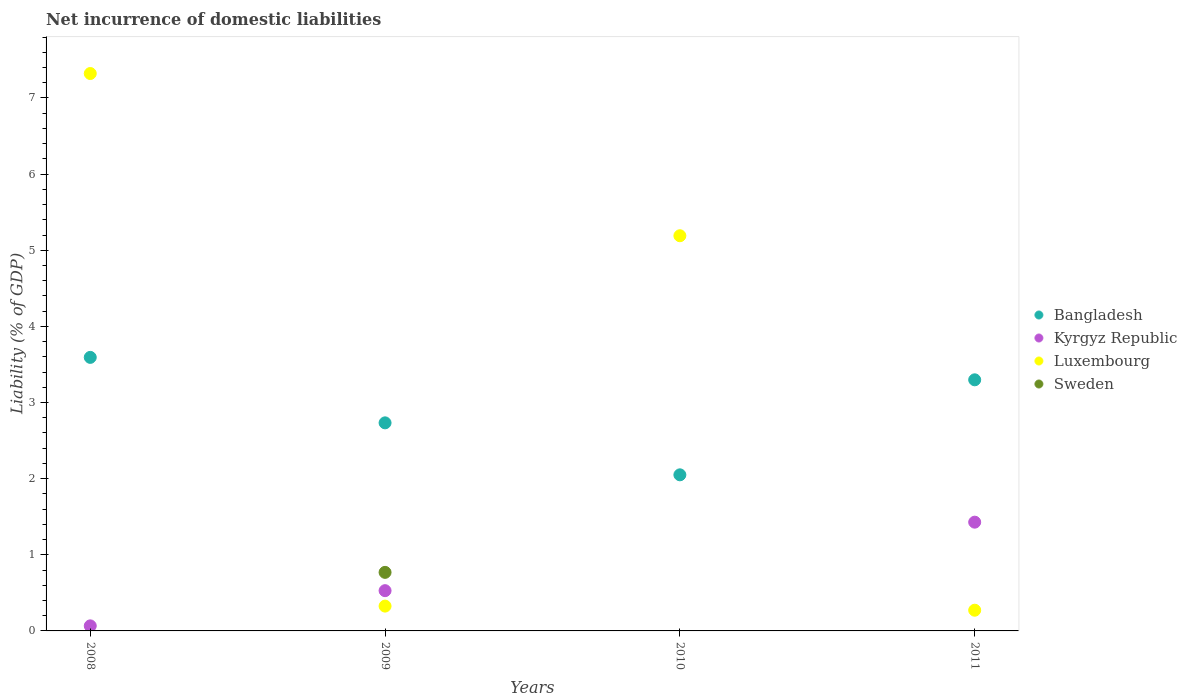Is the number of dotlines equal to the number of legend labels?
Provide a succinct answer. No. What is the net incurrence of domestic liabilities in Kyrgyz Republic in 2009?
Your response must be concise. 0.53. Across all years, what is the maximum net incurrence of domestic liabilities in Sweden?
Your answer should be very brief. 0.77. Across all years, what is the minimum net incurrence of domestic liabilities in Bangladesh?
Keep it short and to the point. 2.05. What is the total net incurrence of domestic liabilities in Bangladesh in the graph?
Ensure brevity in your answer.  11.67. What is the difference between the net incurrence of domestic liabilities in Bangladesh in 2008 and that in 2010?
Give a very brief answer. 1.54. What is the difference between the net incurrence of domestic liabilities in Bangladesh in 2011 and the net incurrence of domestic liabilities in Luxembourg in 2008?
Make the answer very short. -4.02. What is the average net incurrence of domestic liabilities in Bangladesh per year?
Make the answer very short. 2.92. In the year 2011, what is the difference between the net incurrence of domestic liabilities in Kyrgyz Republic and net incurrence of domestic liabilities in Luxembourg?
Your answer should be compact. 1.16. In how many years, is the net incurrence of domestic liabilities in Luxembourg greater than 7.4 %?
Provide a succinct answer. 0. What is the ratio of the net incurrence of domestic liabilities in Luxembourg in 2010 to that in 2011?
Keep it short and to the point. 19.09. Is the net incurrence of domestic liabilities in Luxembourg in 2009 less than that in 2010?
Your answer should be very brief. Yes. Is the difference between the net incurrence of domestic liabilities in Kyrgyz Republic in 2008 and 2009 greater than the difference between the net incurrence of domestic liabilities in Luxembourg in 2008 and 2009?
Your answer should be compact. No. What is the difference between the highest and the second highest net incurrence of domestic liabilities in Luxembourg?
Ensure brevity in your answer.  2.13. What is the difference between the highest and the lowest net incurrence of domestic liabilities in Sweden?
Your response must be concise. 0.77. In how many years, is the net incurrence of domestic liabilities in Sweden greater than the average net incurrence of domestic liabilities in Sweden taken over all years?
Ensure brevity in your answer.  1. Is the net incurrence of domestic liabilities in Sweden strictly greater than the net incurrence of domestic liabilities in Bangladesh over the years?
Offer a terse response. No. How many years are there in the graph?
Ensure brevity in your answer.  4. What is the difference between two consecutive major ticks on the Y-axis?
Your answer should be very brief. 1. Does the graph contain grids?
Make the answer very short. No. How many legend labels are there?
Offer a terse response. 4. How are the legend labels stacked?
Your response must be concise. Vertical. What is the title of the graph?
Keep it short and to the point. Net incurrence of domestic liabilities. What is the label or title of the X-axis?
Keep it short and to the point. Years. What is the label or title of the Y-axis?
Give a very brief answer. Liability (% of GDP). What is the Liability (% of GDP) in Bangladesh in 2008?
Offer a terse response. 3.59. What is the Liability (% of GDP) in Kyrgyz Republic in 2008?
Give a very brief answer. 0.07. What is the Liability (% of GDP) of Luxembourg in 2008?
Offer a very short reply. 7.32. What is the Liability (% of GDP) in Bangladesh in 2009?
Offer a very short reply. 2.73. What is the Liability (% of GDP) of Kyrgyz Republic in 2009?
Offer a terse response. 0.53. What is the Liability (% of GDP) of Luxembourg in 2009?
Offer a terse response. 0.33. What is the Liability (% of GDP) of Sweden in 2009?
Offer a terse response. 0.77. What is the Liability (% of GDP) of Bangladesh in 2010?
Offer a very short reply. 2.05. What is the Liability (% of GDP) in Kyrgyz Republic in 2010?
Keep it short and to the point. 0. What is the Liability (% of GDP) of Luxembourg in 2010?
Keep it short and to the point. 5.19. What is the Liability (% of GDP) of Sweden in 2010?
Give a very brief answer. 0. What is the Liability (% of GDP) in Bangladesh in 2011?
Provide a succinct answer. 3.3. What is the Liability (% of GDP) of Kyrgyz Republic in 2011?
Give a very brief answer. 1.43. What is the Liability (% of GDP) of Luxembourg in 2011?
Your answer should be very brief. 0.27. What is the Liability (% of GDP) in Sweden in 2011?
Offer a terse response. 0. Across all years, what is the maximum Liability (% of GDP) of Bangladesh?
Offer a very short reply. 3.59. Across all years, what is the maximum Liability (% of GDP) in Kyrgyz Republic?
Make the answer very short. 1.43. Across all years, what is the maximum Liability (% of GDP) of Luxembourg?
Your answer should be very brief. 7.32. Across all years, what is the maximum Liability (% of GDP) in Sweden?
Provide a short and direct response. 0.77. Across all years, what is the minimum Liability (% of GDP) of Bangladesh?
Provide a succinct answer. 2.05. Across all years, what is the minimum Liability (% of GDP) of Kyrgyz Republic?
Offer a very short reply. 0. Across all years, what is the minimum Liability (% of GDP) of Luxembourg?
Your response must be concise. 0.27. What is the total Liability (% of GDP) in Bangladesh in the graph?
Keep it short and to the point. 11.67. What is the total Liability (% of GDP) in Kyrgyz Republic in the graph?
Your answer should be very brief. 2.02. What is the total Liability (% of GDP) of Luxembourg in the graph?
Provide a succinct answer. 13.11. What is the total Liability (% of GDP) in Sweden in the graph?
Offer a very short reply. 0.77. What is the difference between the Liability (% of GDP) in Bangladesh in 2008 and that in 2009?
Give a very brief answer. 0.86. What is the difference between the Liability (% of GDP) of Kyrgyz Republic in 2008 and that in 2009?
Provide a succinct answer. -0.46. What is the difference between the Liability (% of GDP) of Luxembourg in 2008 and that in 2009?
Keep it short and to the point. 7. What is the difference between the Liability (% of GDP) of Bangladesh in 2008 and that in 2010?
Your answer should be very brief. 1.54. What is the difference between the Liability (% of GDP) of Luxembourg in 2008 and that in 2010?
Give a very brief answer. 2.13. What is the difference between the Liability (% of GDP) in Bangladesh in 2008 and that in 2011?
Make the answer very short. 0.29. What is the difference between the Liability (% of GDP) of Kyrgyz Republic in 2008 and that in 2011?
Offer a very short reply. -1.36. What is the difference between the Liability (% of GDP) of Luxembourg in 2008 and that in 2011?
Offer a terse response. 7.05. What is the difference between the Liability (% of GDP) in Bangladesh in 2009 and that in 2010?
Give a very brief answer. 0.68. What is the difference between the Liability (% of GDP) in Luxembourg in 2009 and that in 2010?
Give a very brief answer. -4.86. What is the difference between the Liability (% of GDP) of Bangladesh in 2009 and that in 2011?
Keep it short and to the point. -0.57. What is the difference between the Liability (% of GDP) in Kyrgyz Republic in 2009 and that in 2011?
Keep it short and to the point. -0.9. What is the difference between the Liability (% of GDP) in Luxembourg in 2009 and that in 2011?
Provide a short and direct response. 0.05. What is the difference between the Liability (% of GDP) in Bangladesh in 2010 and that in 2011?
Offer a very short reply. -1.25. What is the difference between the Liability (% of GDP) in Luxembourg in 2010 and that in 2011?
Provide a succinct answer. 4.92. What is the difference between the Liability (% of GDP) in Bangladesh in 2008 and the Liability (% of GDP) in Kyrgyz Republic in 2009?
Give a very brief answer. 3.06. What is the difference between the Liability (% of GDP) in Bangladesh in 2008 and the Liability (% of GDP) in Luxembourg in 2009?
Keep it short and to the point. 3.27. What is the difference between the Liability (% of GDP) in Bangladesh in 2008 and the Liability (% of GDP) in Sweden in 2009?
Give a very brief answer. 2.82. What is the difference between the Liability (% of GDP) in Kyrgyz Republic in 2008 and the Liability (% of GDP) in Luxembourg in 2009?
Offer a terse response. -0.26. What is the difference between the Liability (% of GDP) of Kyrgyz Republic in 2008 and the Liability (% of GDP) of Sweden in 2009?
Give a very brief answer. -0.7. What is the difference between the Liability (% of GDP) in Luxembourg in 2008 and the Liability (% of GDP) in Sweden in 2009?
Offer a terse response. 6.55. What is the difference between the Liability (% of GDP) in Bangladesh in 2008 and the Liability (% of GDP) in Luxembourg in 2010?
Ensure brevity in your answer.  -1.6. What is the difference between the Liability (% of GDP) of Kyrgyz Republic in 2008 and the Liability (% of GDP) of Luxembourg in 2010?
Your response must be concise. -5.12. What is the difference between the Liability (% of GDP) of Bangladesh in 2008 and the Liability (% of GDP) of Kyrgyz Republic in 2011?
Provide a succinct answer. 2.16. What is the difference between the Liability (% of GDP) in Bangladesh in 2008 and the Liability (% of GDP) in Luxembourg in 2011?
Offer a terse response. 3.32. What is the difference between the Liability (% of GDP) of Kyrgyz Republic in 2008 and the Liability (% of GDP) of Luxembourg in 2011?
Give a very brief answer. -0.21. What is the difference between the Liability (% of GDP) in Bangladesh in 2009 and the Liability (% of GDP) in Luxembourg in 2010?
Your answer should be very brief. -2.46. What is the difference between the Liability (% of GDP) of Kyrgyz Republic in 2009 and the Liability (% of GDP) of Luxembourg in 2010?
Offer a very short reply. -4.66. What is the difference between the Liability (% of GDP) of Bangladesh in 2009 and the Liability (% of GDP) of Kyrgyz Republic in 2011?
Your response must be concise. 1.3. What is the difference between the Liability (% of GDP) of Bangladesh in 2009 and the Liability (% of GDP) of Luxembourg in 2011?
Provide a succinct answer. 2.46. What is the difference between the Liability (% of GDP) in Kyrgyz Republic in 2009 and the Liability (% of GDP) in Luxembourg in 2011?
Give a very brief answer. 0.26. What is the difference between the Liability (% of GDP) in Bangladesh in 2010 and the Liability (% of GDP) in Kyrgyz Republic in 2011?
Make the answer very short. 0.62. What is the difference between the Liability (% of GDP) in Bangladesh in 2010 and the Liability (% of GDP) in Luxembourg in 2011?
Keep it short and to the point. 1.78. What is the average Liability (% of GDP) of Bangladesh per year?
Your response must be concise. 2.92. What is the average Liability (% of GDP) in Kyrgyz Republic per year?
Your response must be concise. 0.51. What is the average Liability (% of GDP) in Luxembourg per year?
Offer a terse response. 3.28. What is the average Liability (% of GDP) in Sweden per year?
Your response must be concise. 0.19. In the year 2008, what is the difference between the Liability (% of GDP) in Bangladesh and Liability (% of GDP) in Kyrgyz Republic?
Provide a short and direct response. 3.53. In the year 2008, what is the difference between the Liability (% of GDP) of Bangladesh and Liability (% of GDP) of Luxembourg?
Ensure brevity in your answer.  -3.73. In the year 2008, what is the difference between the Liability (% of GDP) of Kyrgyz Republic and Liability (% of GDP) of Luxembourg?
Your answer should be compact. -7.25. In the year 2009, what is the difference between the Liability (% of GDP) in Bangladesh and Liability (% of GDP) in Kyrgyz Republic?
Offer a terse response. 2.2. In the year 2009, what is the difference between the Liability (% of GDP) of Bangladesh and Liability (% of GDP) of Luxembourg?
Offer a very short reply. 2.41. In the year 2009, what is the difference between the Liability (% of GDP) of Bangladesh and Liability (% of GDP) of Sweden?
Keep it short and to the point. 1.96. In the year 2009, what is the difference between the Liability (% of GDP) of Kyrgyz Republic and Liability (% of GDP) of Luxembourg?
Your response must be concise. 0.2. In the year 2009, what is the difference between the Liability (% of GDP) in Kyrgyz Republic and Liability (% of GDP) in Sweden?
Provide a succinct answer. -0.24. In the year 2009, what is the difference between the Liability (% of GDP) of Luxembourg and Liability (% of GDP) of Sweden?
Provide a succinct answer. -0.44. In the year 2010, what is the difference between the Liability (% of GDP) in Bangladesh and Liability (% of GDP) in Luxembourg?
Ensure brevity in your answer.  -3.14. In the year 2011, what is the difference between the Liability (% of GDP) of Bangladesh and Liability (% of GDP) of Kyrgyz Republic?
Provide a succinct answer. 1.87. In the year 2011, what is the difference between the Liability (% of GDP) of Bangladesh and Liability (% of GDP) of Luxembourg?
Provide a short and direct response. 3.03. In the year 2011, what is the difference between the Liability (% of GDP) of Kyrgyz Republic and Liability (% of GDP) of Luxembourg?
Offer a terse response. 1.16. What is the ratio of the Liability (% of GDP) of Bangladesh in 2008 to that in 2009?
Make the answer very short. 1.31. What is the ratio of the Liability (% of GDP) in Kyrgyz Republic in 2008 to that in 2009?
Offer a terse response. 0.13. What is the ratio of the Liability (% of GDP) of Luxembourg in 2008 to that in 2009?
Your answer should be very brief. 22.46. What is the ratio of the Liability (% of GDP) of Bangladesh in 2008 to that in 2010?
Offer a terse response. 1.75. What is the ratio of the Liability (% of GDP) of Luxembourg in 2008 to that in 2010?
Give a very brief answer. 1.41. What is the ratio of the Liability (% of GDP) in Bangladesh in 2008 to that in 2011?
Make the answer very short. 1.09. What is the ratio of the Liability (% of GDP) of Kyrgyz Republic in 2008 to that in 2011?
Ensure brevity in your answer.  0.05. What is the ratio of the Liability (% of GDP) of Luxembourg in 2008 to that in 2011?
Provide a succinct answer. 26.92. What is the ratio of the Liability (% of GDP) of Bangladesh in 2009 to that in 2010?
Provide a short and direct response. 1.33. What is the ratio of the Liability (% of GDP) of Luxembourg in 2009 to that in 2010?
Provide a short and direct response. 0.06. What is the ratio of the Liability (% of GDP) in Bangladesh in 2009 to that in 2011?
Give a very brief answer. 0.83. What is the ratio of the Liability (% of GDP) in Kyrgyz Republic in 2009 to that in 2011?
Make the answer very short. 0.37. What is the ratio of the Liability (% of GDP) in Luxembourg in 2009 to that in 2011?
Give a very brief answer. 1.2. What is the ratio of the Liability (% of GDP) in Bangladesh in 2010 to that in 2011?
Give a very brief answer. 0.62. What is the ratio of the Liability (% of GDP) in Luxembourg in 2010 to that in 2011?
Offer a terse response. 19.09. What is the difference between the highest and the second highest Liability (% of GDP) of Bangladesh?
Give a very brief answer. 0.29. What is the difference between the highest and the second highest Liability (% of GDP) of Kyrgyz Republic?
Your answer should be compact. 0.9. What is the difference between the highest and the second highest Liability (% of GDP) in Luxembourg?
Keep it short and to the point. 2.13. What is the difference between the highest and the lowest Liability (% of GDP) in Bangladesh?
Ensure brevity in your answer.  1.54. What is the difference between the highest and the lowest Liability (% of GDP) of Kyrgyz Republic?
Your answer should be very brief. 1.43. What is the difference between the highest and the lowest Liability (% of GDP) of Luxembourg?
Your answer should be compact. 7.05. What is the difference between the highest and the lowest Liability (% of GDP) of Sweden?
Provide a short and direct response. 0.77. 